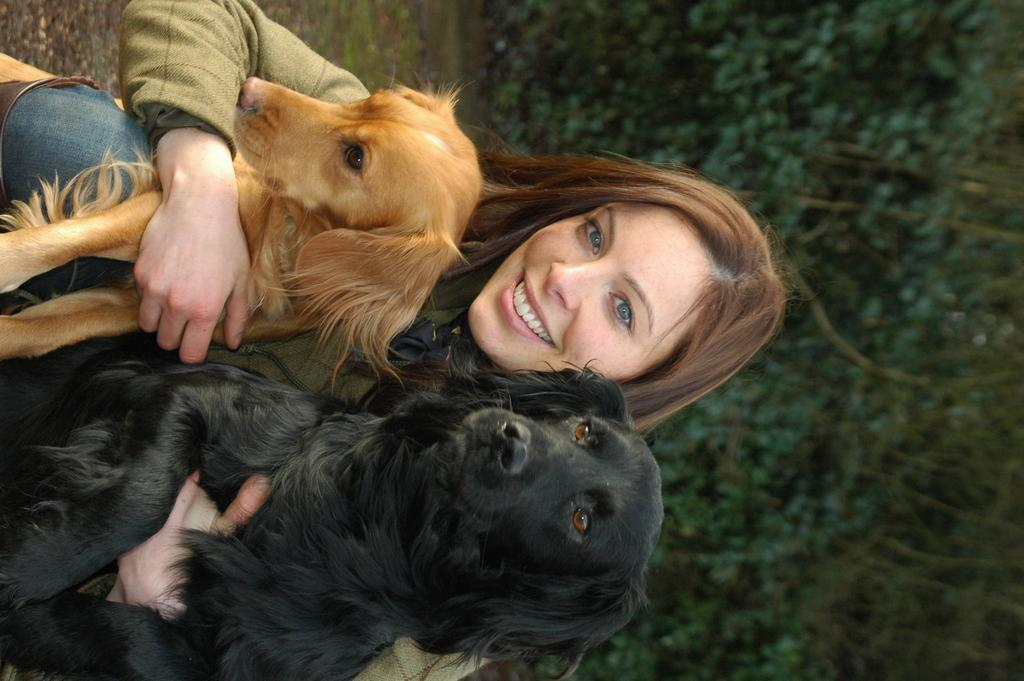What can be seen in the background of the image? There are trees in the background of the image. Who is present in the image? There is a woman in the image. What is the woman doing? The woman is smiling. What is the woman holding in her lap? There are dogs in the woman's lap. Can you describe the dogs in the woman's lap? One of the dogs is black, and the other is brown. What type of lettuce is the woman using to knit a scarf for the tramp in the image? There is no lettuce or tramp present in the image, and the woman is not knitting a scarf. 